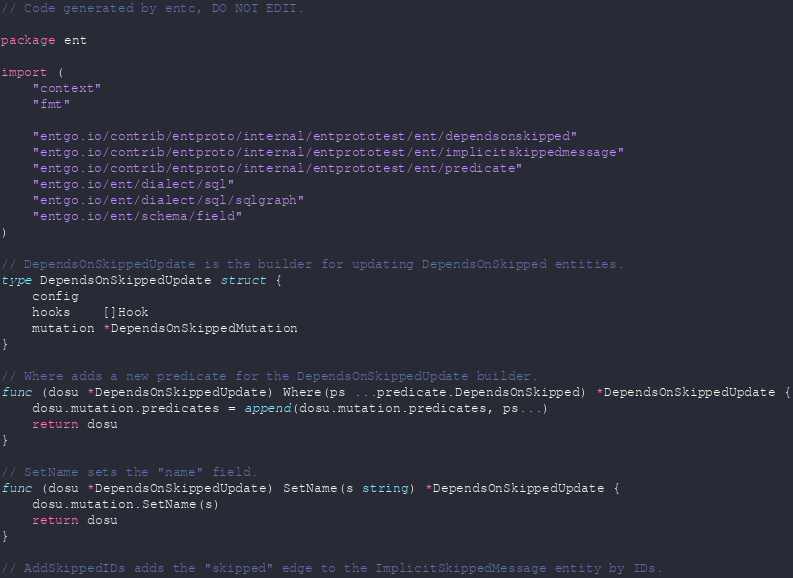<code> <loc_0><loc_0><loc_500><loc_500><_Go_>// Code generated by entc, DO NOT EDIT.

package ent

import (
	"context"
	"fmt"

	"entgo.io/contrib/entproto/internal/entprototest/ent/dependsonskipped"
	"entgo.io/contrib/entproto/internal/entprototest/ent/implicitskippedmessage"
	"entgo.io/contrib/entproto/internal/entprototest/ent/predicate"
	"entgo.io/ent/dialect/sql"
	"entgo.io/ent/dialect/sql/sqlgraph"
	"entgo.io/ent/schema/field"
)

// DependsOnSkippedUpdate is the builder for updating DependsOnSkipped entities.
type DependsOnSkippedUpdate struct {
	config
	hooks    []Hook
	mutation *DependsOnSkippedMutation
}

// Where adds a new predicate for the DependsOnSkippedUpdate builder.
func (dosu *DependsOnSkippedUpdate) Where(ps ...predicate.DependsOnSkipped) *DependsOnSkippedUpdate {
	dosu.mutation.predicates = append(dosu.mutation.predicates, ps...)
	return dosu
}

// SetName sets the "name" field.
func (dosu *DependsOnSkippedUpdate) SetName(s string) *DependsOnSkippedUpdate {
	dosu.mutation.SetName(s)
	return dosu
}

// AddSkippedIDs adds the "skipped" edge to the ImplicitSkippedMessage entity by IDs.</code> 